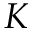<formula> <loc_0><loc_0><loc_500><loc_500>K</formula> 